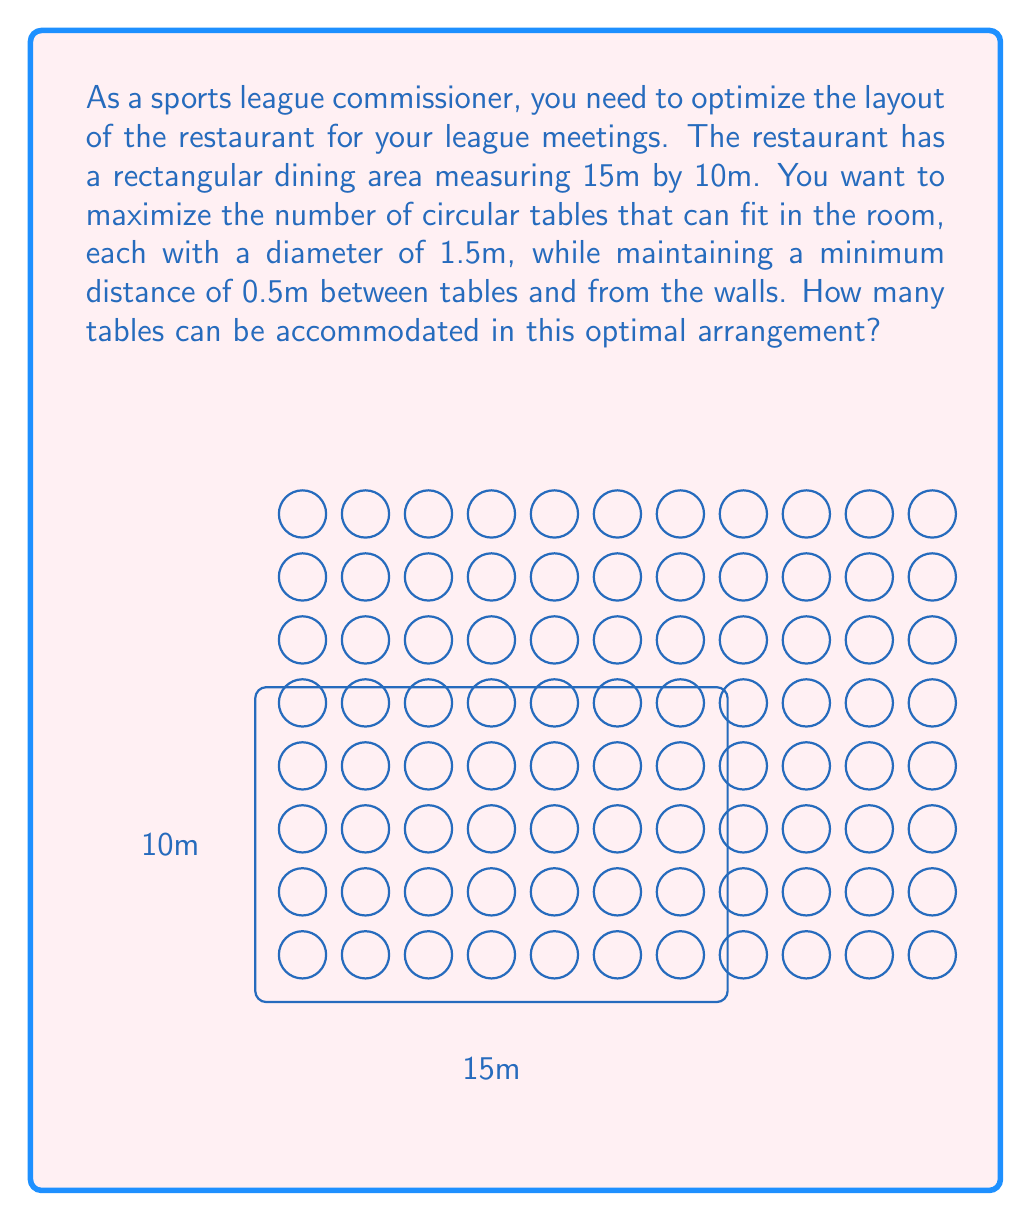Solve this math problem. To solve this problem, we'll use concepts from packing theory in topology. Let's approach this step-by-step:

1) First, we need to calculate the effective space each table occupies, including the minimum distance:
   Effective diameter = Table diameter + 2 * Minimum distance
   $$ 1.5m + 2 * 0.5m = 2.5m $$

2) Now, we can treat this as a grid packing problem. We'll calculate how many of these 2.5m circles can fit along each dimension:

   Along 15m side: $$ \lfloor \frac{15m - 0.5m}{2.5m} \rfloor = \lfloor 5.8 \rfloor = 5 $$
   Along 10m side: $$ \lfloor \frac{10m - 0.5m}{2.5m} \rfloor = \lfloor 3.8 \rfloor = 3 $$

   Note: We subtract 0.5m from each dimension to account for the distance from the walls, and use the floor function to get the integer number of tables.

3) The total number of tables is the product of these two values:
   $$ 5 * 3 = 15 $$

4) To verify, we can calculate the space this arrangement would occupy:
   Width: $$ 0.5m + (5 * 2.5m) = 13m \leq 15m $$
   Height: $$ 0.5m + (3 * 2.5m) = 8m \leq 10m $$

   This confirms that our arrangement fits within the given dimensions while maintaining the required distances.

Therefore, the optimal arrangement can accommodate 15 tables.
Answer: 15 tables 